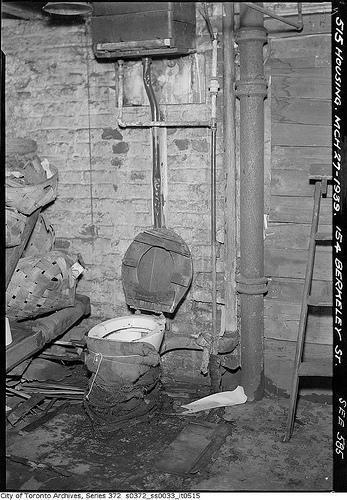How many toilets are there?
Give a very brief answer. 1. 